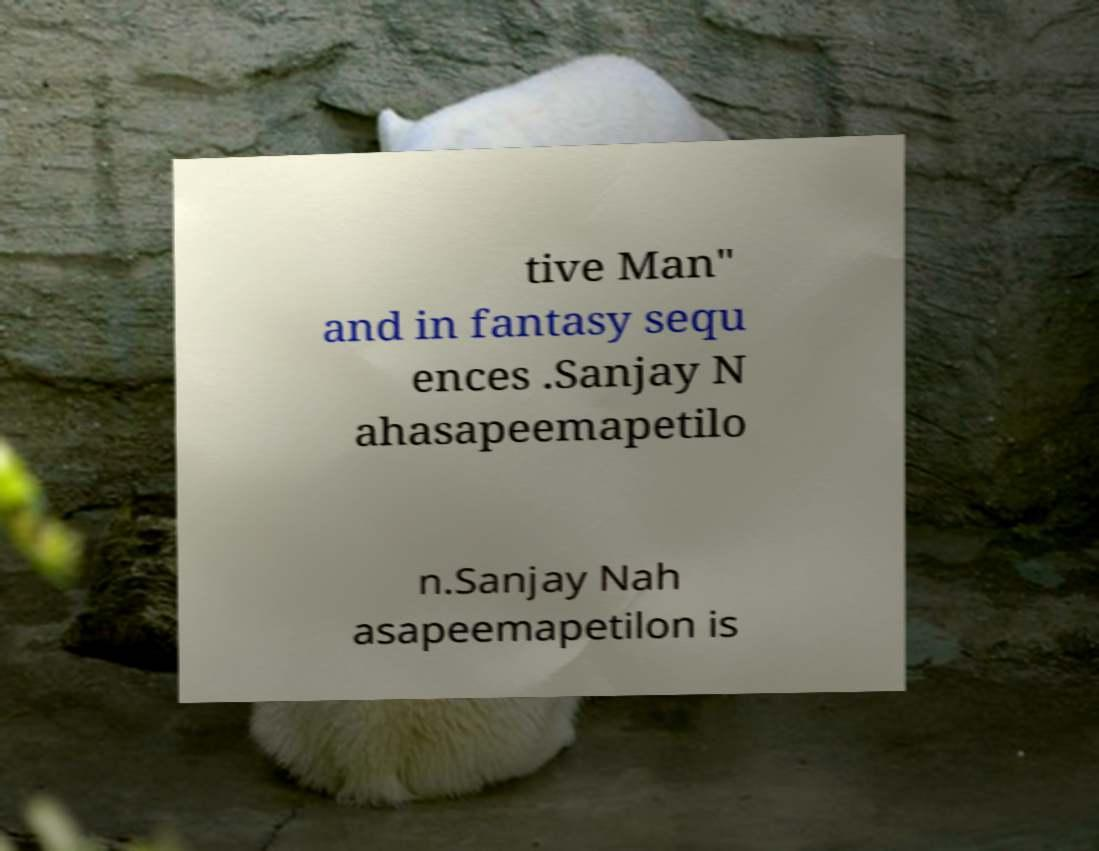What messages or text are displayed in this image? I need them in a readable, typed format. tive Man" and in fantasy sequ ences .Sanjay N ahasapeemapetilo n.Sanjay Nah asapeemapetilon is 